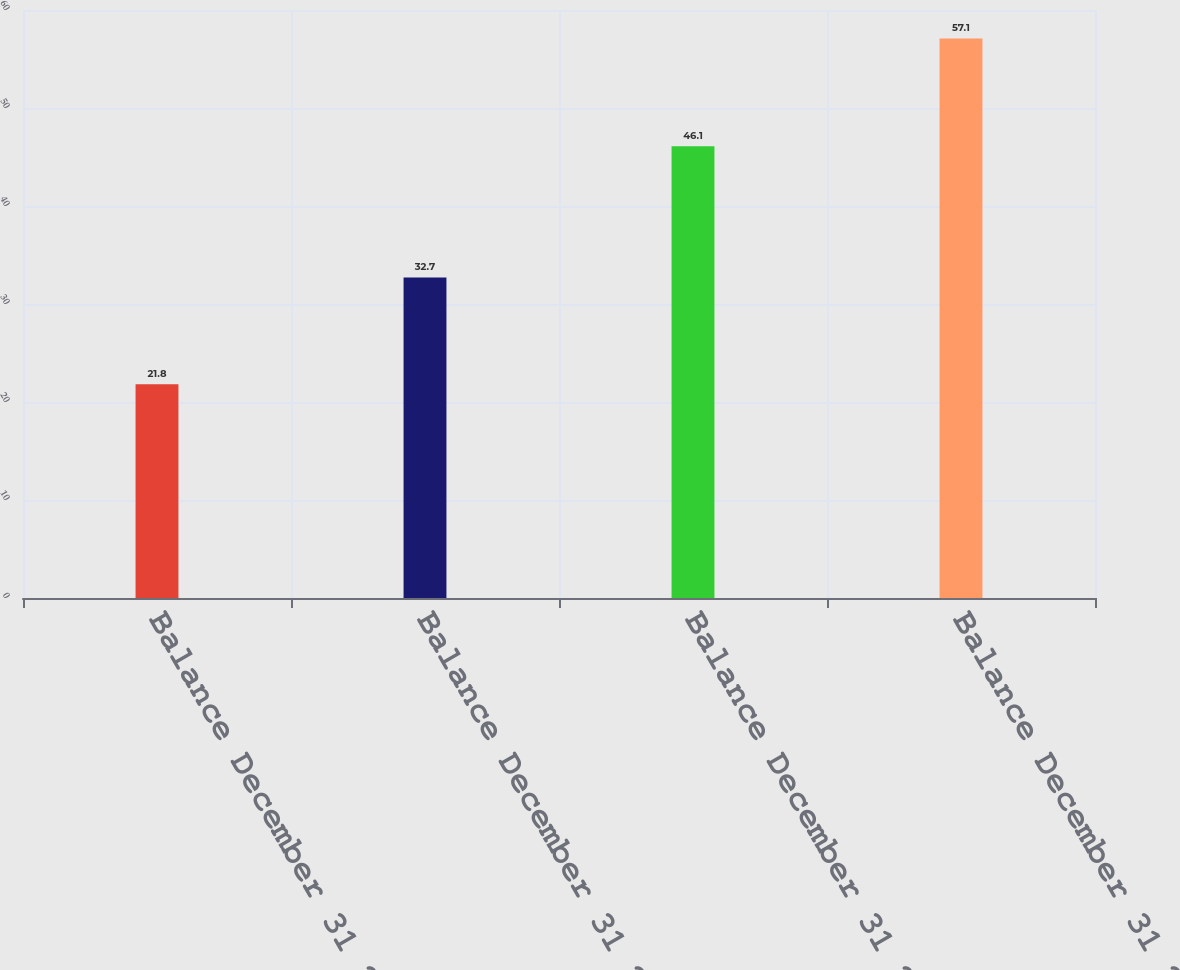Convert chart to OTSL. <chart><loc_0><loc_0><loc_500><loc_500><bar_chart><fcel>Balance December 31 2003<fcel>Balance December 31 2004<fcel>Balance December 31 2005<fcel>Balance December 31 2006<nl><fcel>21.8<fcel>32.7<fcel>46.1<fcel>57.1<nl></chart> 